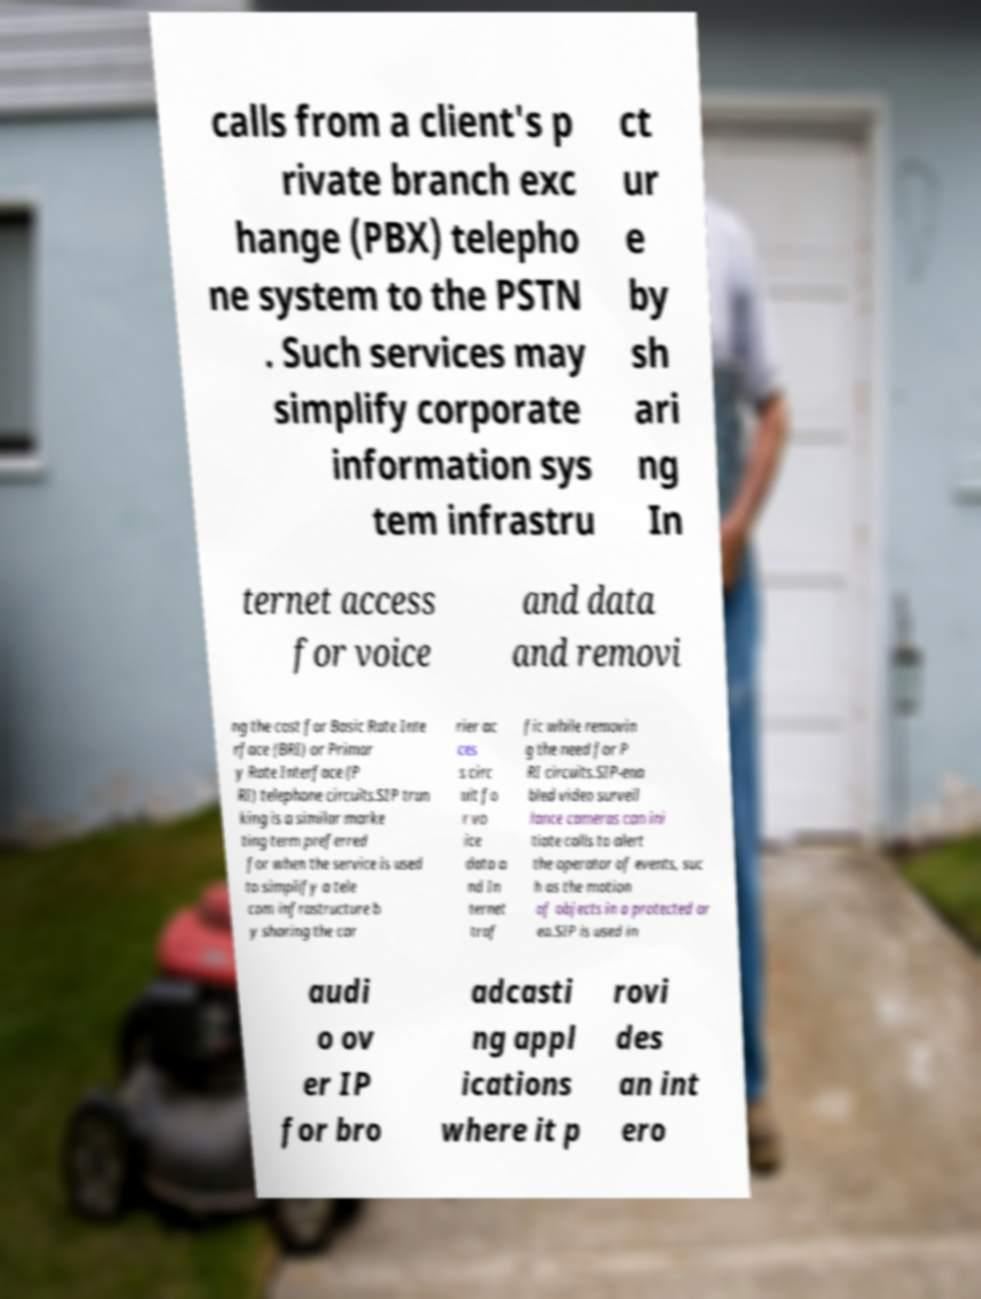Can you read and provide the text displayed in the image?This photo seems to have some interesting text. Can you extract and type it out for me? calls from a client's p rivate branch exc hange (PBX) telepho ne system to the PSTN . Such services may simplify corporate information sys tem infrastru ct ur e by sh ari ng In ternet access for voice and data and removi ng the cost for Basic Rate Inte rface (BRI) or Primar y Rate Interface (P RI) telephone circuits.SIP trun king is a similar marke ting term preferred for when the service is used to simplify a tele com infrastructure b y sharing the car rier ac ces s circ uit fo r vo ice data a nd In ternet traf fic while removin g the need for P RI circuits.SIP-ena bled video surveil lance cameras can ini tiate calls to alert the operator of events, suc h as the motion of objects in a protected ar ea.SIP is used in audi o ov er IP for bro adcasti ng appl ications where it p rovi des an int ero 